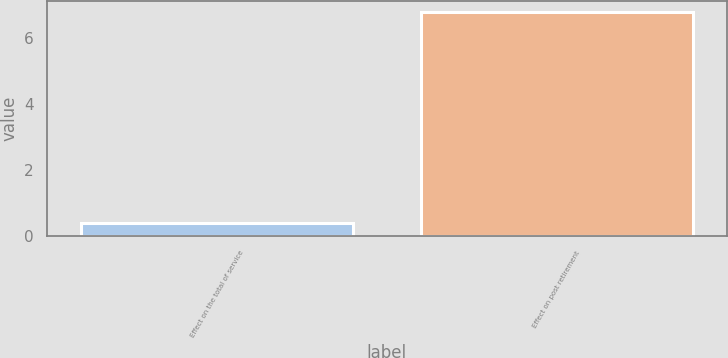Convert chart to OTSL. <chart><loc_0><loc_0><loc_500><loc_500><bar_chart><fcel>Effect on the total of service<fcel>Effect on post retirement<nl><fcel>0.4<fcel>6.8<nl></chart> 